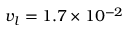<formula> <loc_0><loc_0><loc_500><loc_500>{ v _ { l } } 1 . 7 \times { 1 0 ^ { - 2 } }</formula> 